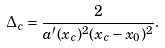Convert formula to latex. <formula><loc_0><loc_0><loc_500><loc_500>\Delta _ { c } = \frac { 2 } { a ^ { \prime } ( x _ { c } ) ^ { 2 } ( x _ { c } - x _ { 0 } ) ^ { 2 } } .</formula> 